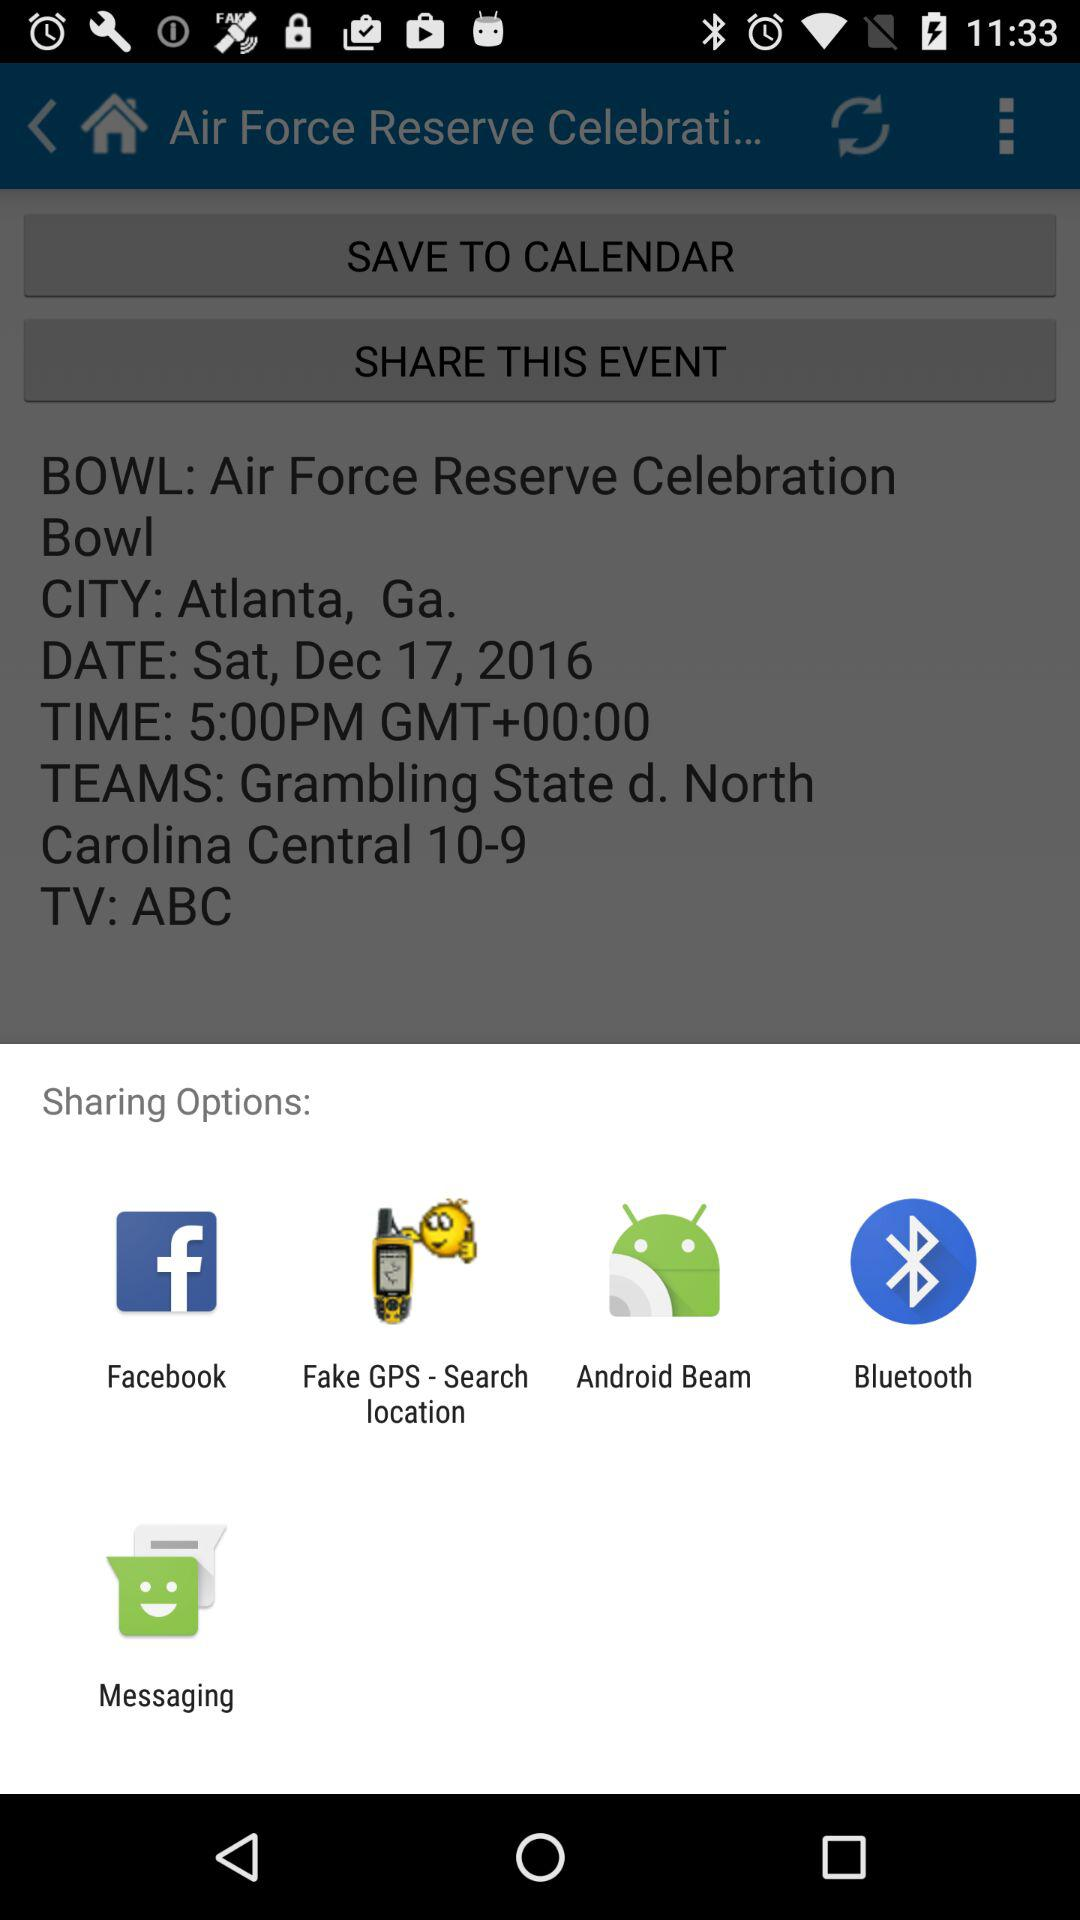Which applications can I use to share the content? You can use "Facebook", "Fake GPS - Search location", "Android Beam", "Bluetooth" and "Messaging" to share the content. 